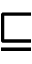<formula> <loc_0><loc_0><loc_500><loc_500>\sqsubseteq</formula> 